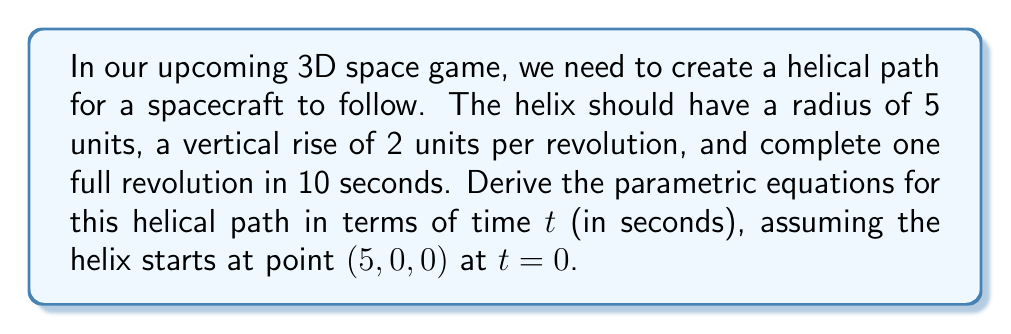Give your solution to this math problem. Let's approach this step-by-step:

1) A helix can be described using parametric equations in the form:
   $$x = r \cos(\omega t)$$
   $$y = r \sin(\omega t)$$
   $$z = bt$$

   Where:
   - r is the radius of the helix
   - ω (omega) is the angular velocity in radians per second
   - b is the vertical rise per radian

2) We're given:
   - Radius r = 5 units
   - One revolution takes 10 seconds
   - Vertical rise is 2 units per revolution

3) Calculate ω:
   - One revolution is 2π radians
   - ω = 2π radians / 10 seconds = π/5 radians/second

4) Calculate b:
   - In one revolution (2π radians), we rise 2 units
   - b = 2 units / 2π radians = 1/π units/radian

5) Now we can write our parametric equations:
   $$x = 5 \cos(\frac{\pi}{5}t)$$
   $$y = 5 \sin(\frac{\pi}{5}t)$$
   $$z = \frac{1}{\pi}t$$

6) However, we need to adjust for the starting point (5, 0, 0):
   - The x and y equations are already correct (at t=0, x=5 and y=0)
   - We need to add 5 to the z equation to start at z=0

Therefore, our final parametric equations are:
   $$x = 5 \cos(\frac{\pi}{5}t)$$
   $$y = 5 \sin(\frac{\pi}{5}t)$$
   $$z = \frac{1}{\pi}t$$
Answer: $$x = 5 \cos(\frac{\pi}{5}t), y = 5 \sin(\frac{\pi}{5}t), z = \frac{1}{\pi}t$$ 